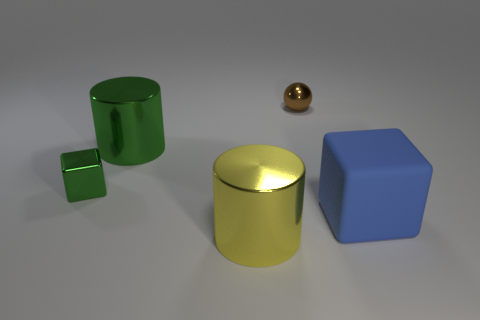The other shiny object that is the same shape as the big green shiny object is what size?
Offer a terse response. Large. There is a cylinder that is the same color as the small metal block; what is it made of?
Provide a short and direct response. Metal. How many objects are green metallic blocks or large green cylinders?
Give a very brief answer. 2. What is the shape of the large object that is to the right of the tiny brown sphere?
Your response must be concise. Cube. What color is the block that is the same material as the small ball?
Offer a very short reply. Green. What is the material of the big green thing that is the same shape as the yellow metal object?
Ensure brevity in your answer.  Metal. What shape is the yellow thing?
Your answer should be very brief. Cylinder. There is a large object that is right of the green metal cylinder and left of the large rubber block; what is its material?
Provide a short and direct response. Metal. There is a tiny brown thing that is made of the same material as the yellow thing; what shape is it?
Offer a terse response. Sphere. What size is the yellow object that is the same material as the small brown ball?
Your answer should be compact. Large. 